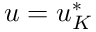<formula> <loc_0><loc_0><loc_500><loc_500>u = u _ { K } ^ { * }</formula> 